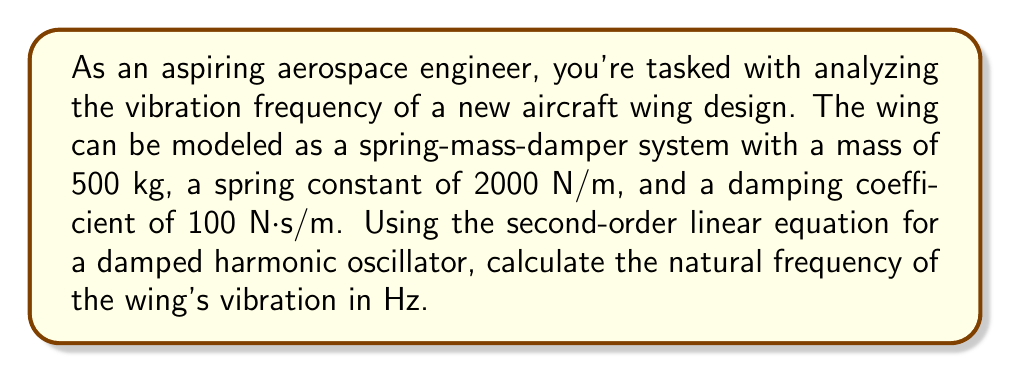Help me with this question. To solve this problem, we'll use the second-order linear equation for a damped harmonic oscillator:

$$m\frac{d^2x}{dt^2} + c\frac{dx}{dt} + kx = 0$$

Where:
$m$ = mass (kg)
$c$ = damping coefficient (N·s/m)
$k$ = spring constant (N/m)
$x$ = displacement (m)
$t$ = time (s)

The natural frequency of the system (ω₀) is given by:

$$\omega_0 = \sqrt{\frac{k}{m}}$$

Given:
$m = 500$ kg
$k = 2000$ N/m
$c = 100$ N·s/m (not needed for this calculation)

Let's calculate the natural frequency:

$$\omega_0 = \sqrt{\frac{2000}{500}} = \sqrt{4} = 2 \text{ rad/s}$$

To convert from radians per second to Hz, we use the formula:

$$f = \frac{\omega_0}{2\pi}$$

Substituting our value:

$$f = \frac{2}{2\pi} = \frac{1}{\pi} \approx 0.3183 \text{ Hz}$$

Therefore, the natural frequency of the wing's vibration is approximately 0.3183 Hz.
Answer: 0.3183 Hz 